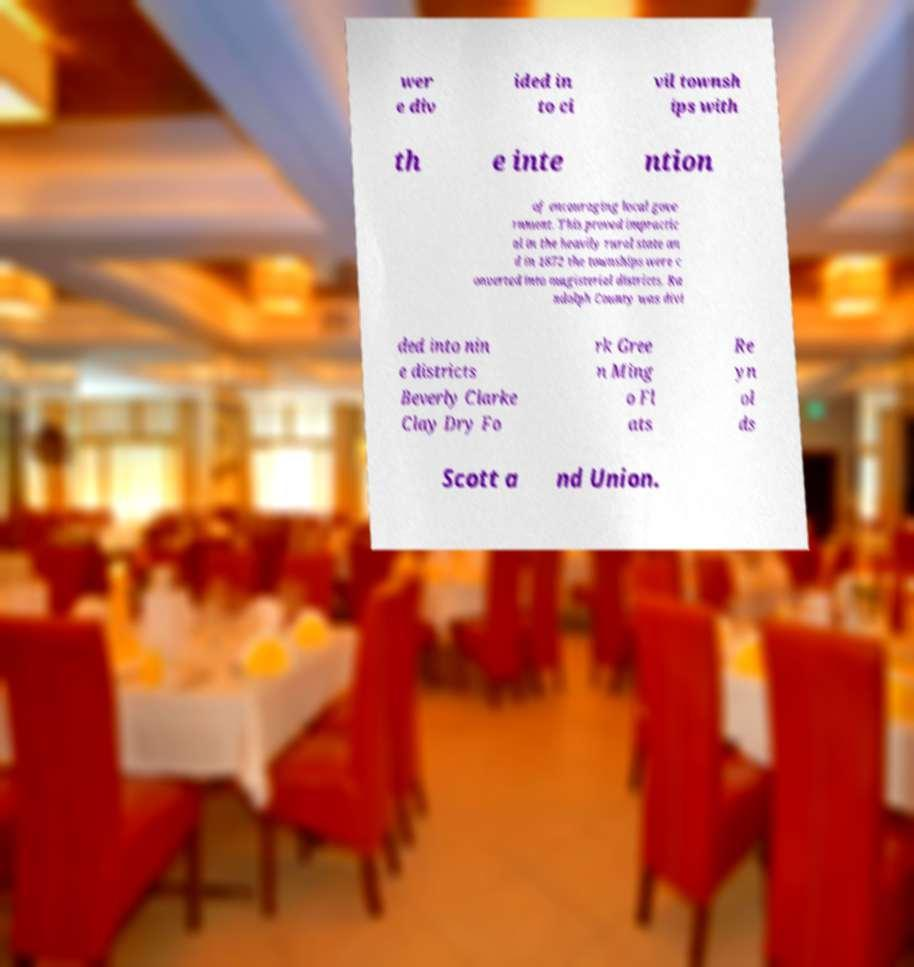Please identify and transcribe the text found in this image. wer e div ided in to ci vil townsh ips with th e inte ntion of encouraging local gove rnment. This proved impractic al in the heavily rural state an d in 1872 the townships were c onverted into magisterial districts. Ra ndolph County was divi ded into nin e districts Beverly Clarke Clay Dry Fo rk Gree n Ming o Fl ats Re yn ol ds Scott a nd Union. 